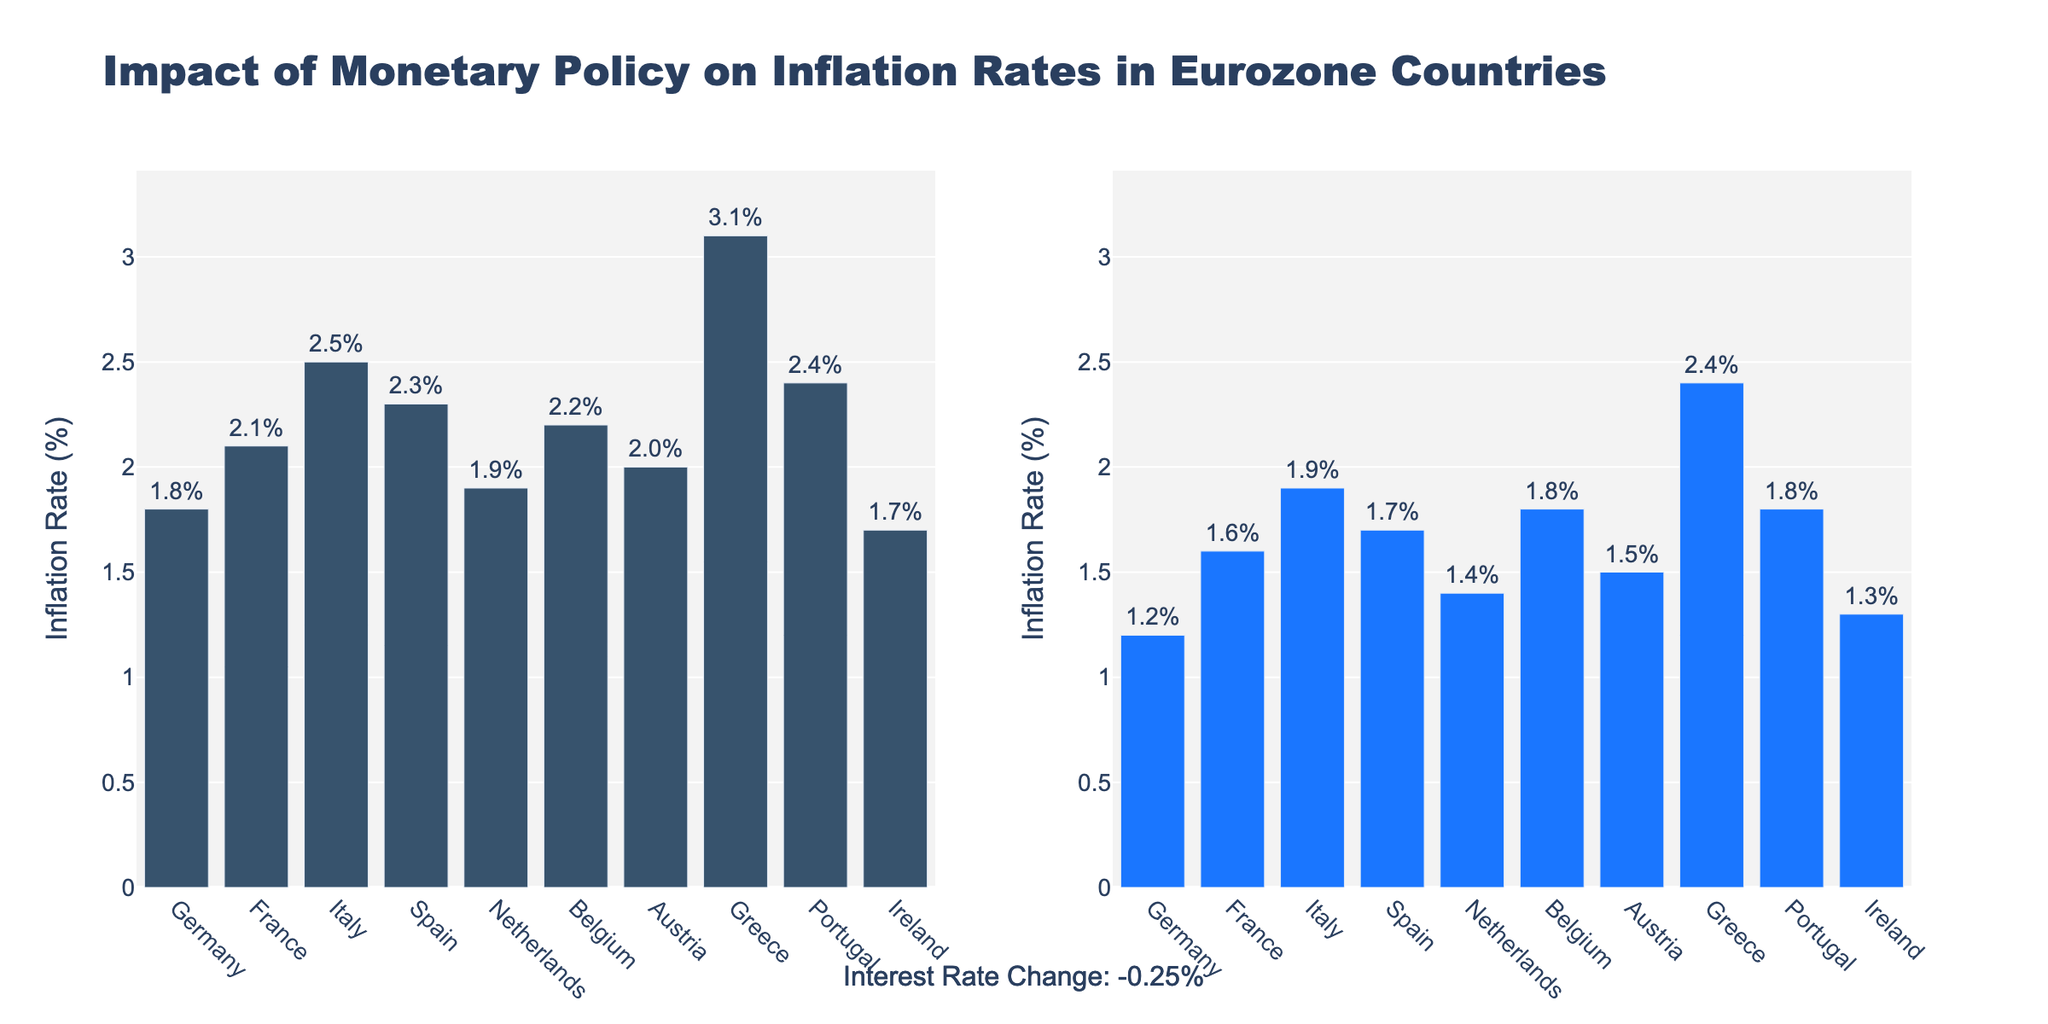Which subfield had the highest number of citations in 2022? To find the highest number of citations for each subfield in 2022, locate the data point for the year 2022 in each subplot. Compare the y-values (citations). Deep Learning has the highest citations (3300) in 2022.
Answer: Deep Learning How did the number of citations in Reinforcement Learning change from 2013 to 2020? Identify the data points for Reinforcement Learning in 2013 and 2020 in its subplot. The citations increased from 980 in 2013 to 2500 in 2020, representing a significant rise.
Answer: Increased Which conference had the highest number of citations in the Computer Vision subfield in 2017? Find the subdivisions related to Computer Vision in the subplot. In 2017, CVPR had the highest citations in Computer Vision with 2400 citations.
Answer: CVPR What was the trend in citations for Generative Models from 2015 to 2021? Observe the Generative Models subplot. Note the values for each year from 2015 (1100 citations) to 2021 (2600 citations). The number of citations shows an increasing trend over these years.
Answer: Increasing Which subfield experienced the largest increase in citations from its initial to its final year? For each subfield, calculate the difference in citations between their initial and final years. For Deep Learning from 2013 (1250 citations) to 2022 (3300 citations), the increase is 2050, which is the largest compared to other subfields.
Answer: Deep Learning What is the average number of citations for Natural Language Processing in the years provided? Use the Natural Language Processing subplot to find the citations for each year provided (820 in 2014, 1450 in 2016, and 2100 in 2020). The average is calculated as (820 + 1450 + 2100)/3 = 1437
Answer: 1437 In which year did Deep Learning reach over 2000 citations for the first time? Look at the Deep Learning subplot and observe the citations for each year. The year is 2016 when citations were 2200, first reaching over 2000.
Answer: 2016 How does the citation pattern of Data Mining compare between 2015 and 2019? Examine the Data Mining subplot to compare the citations in 2015 (750 citations) and 2019 (1300 citations). Citations increased from 2015 to 2019.
Answer: Increased Which subfield had a citation count of 1950 in 2018? Check the citation values for 2018 in each subplot. The citation count of 1950 in that year belongs to Generative Models.
Answer: Generative Models 